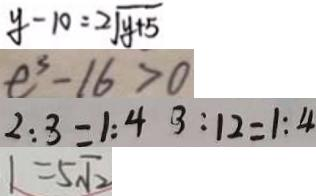Convert formula to latex. <formula><loc_0><loc_0><loc_500><loc_500>y - 1 0 = 2 \sqrt { y + 5 } 
 e ^ { 3 } - 1 6 > 0 
 2 : 3 = 1 : 4 3 : 1 2 = 1 : 4 
 1 = 5 \sqrt { 2 }</formula> 